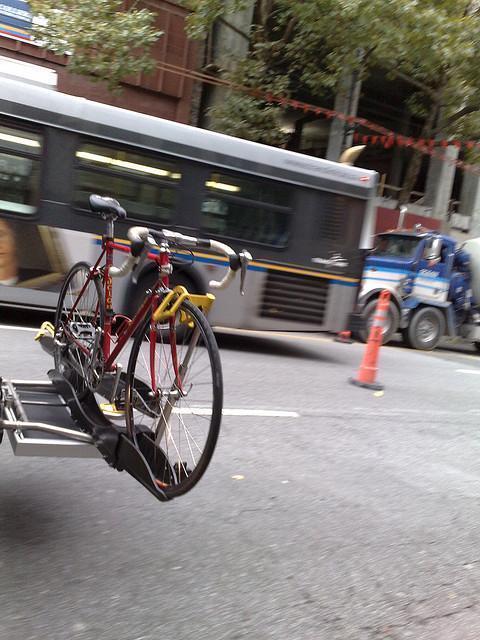What is to the left of the cone?
Make your selection from the four choices given to correctly answer the question.
Options: Helicopter, bicycle, television, bear. Bicycle. 